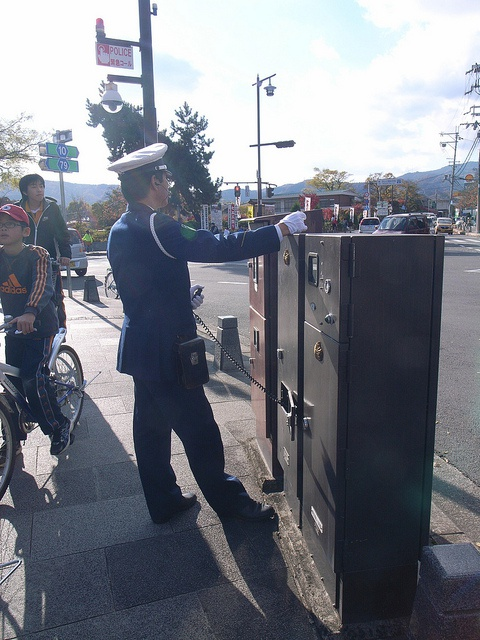Describe the objects in this image and their specific colors. I can see people in white, black, navy, gray, and darkblue tones, people in white, black, gray, and darkblue tones, bicycle in white, gray, black, and lightgray tones, people in white, gray, blue, and darkblue tones, and handbag in white, black, gray, and darkblue tones in this image. 